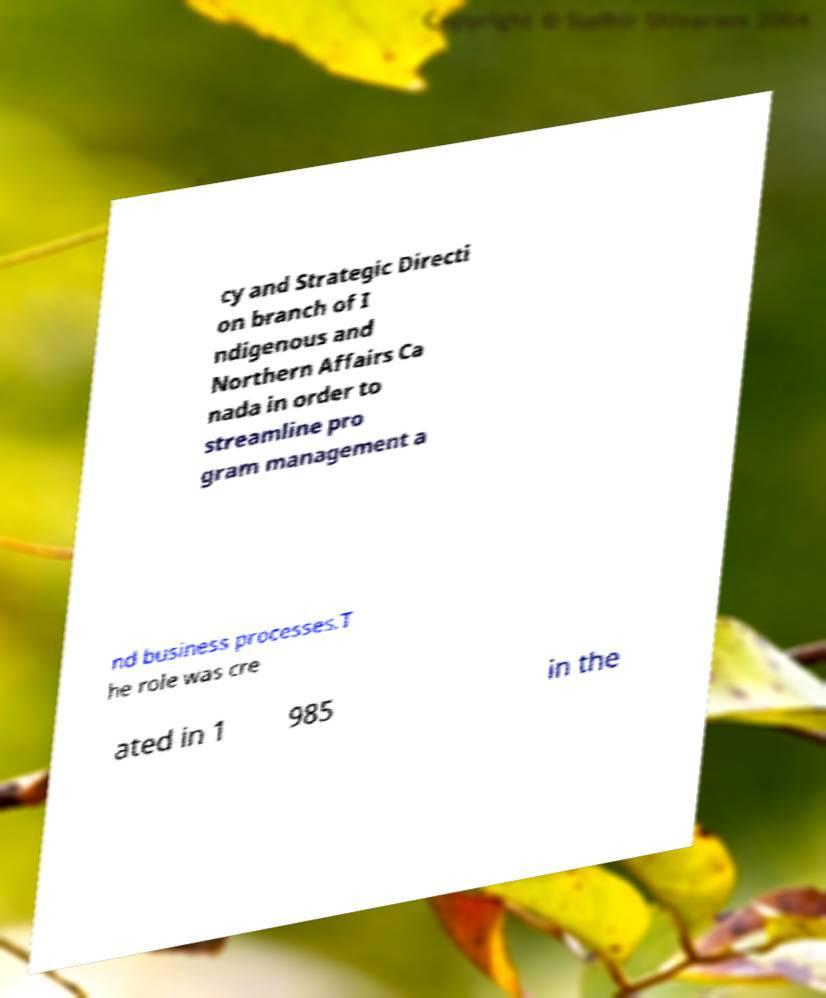Can you accurately transcribe the text from the provided image for me? cy and Strategic Directi on branch of I ndigenous and Northern Affairs Ca nada in order to streamline pro gram management a nd business processes.T he role was cre ated in 1 985 in the 